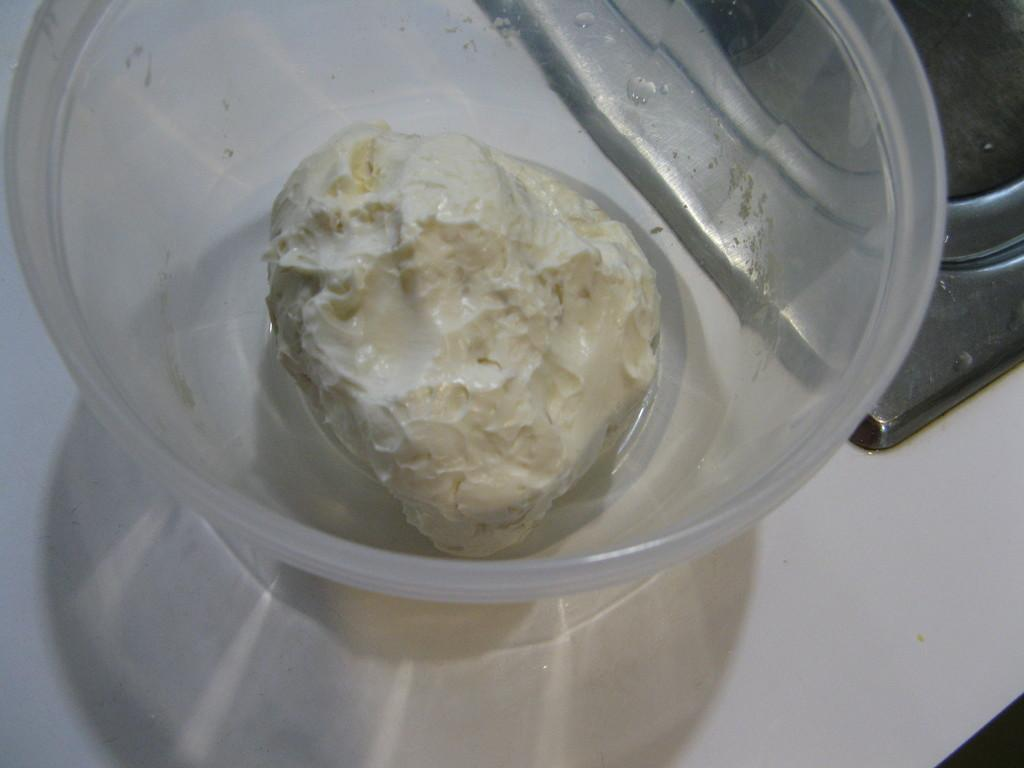What is located in the center of the image? There is a table in the center of the image. What is on top of the table? There is a bowl and a sink on the table. What can be found inside the bowl? There is a food item in the bowl. How many cacti are present on the table in the image? There are no cacti present on the table in the image. What type of cap is being used to cover the food item in the bowl? There is no cap visible in the image; the food item is not covered. 